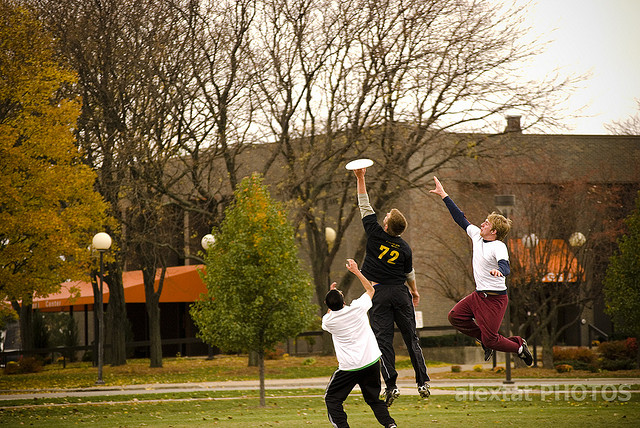What might be the emotional impact of this game on the players? This intense game of Frisbee likely boosts the players' morale and camaraderie. The thrill of the chase and the joy of successful teamwork contribute to a sense of achievement and joy. Competing outdoors, especially in such a spirited setting, also offers a refreshing break from daily routines, promoting relaxation and mental well-being. 